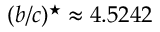Convert formula to latex. <formula><loc_0><loc_0><loc_500><loc_500>( b / c ) ^ { ^ { * } } \approx 4 . 5 2 4 2</formula> 